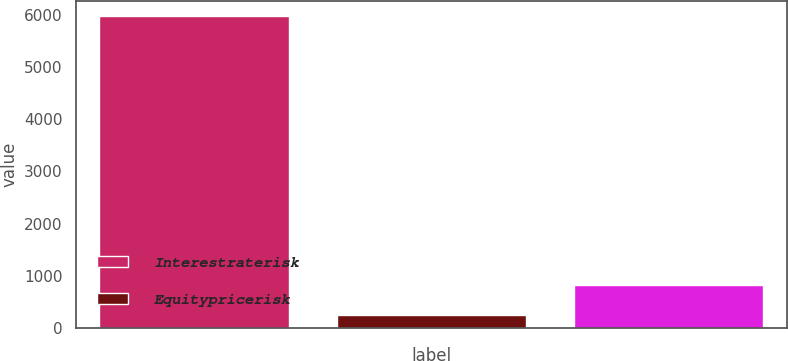<chart> <loc_0><loc_0><loc_500><loc_500><bar_chart><fcel>Interestraterisk<fcel>Equitypricerisk<fcel>Unnamed: 2<nl><fcel>5975<fcel>241<fcel>814.4<nl></chart> 